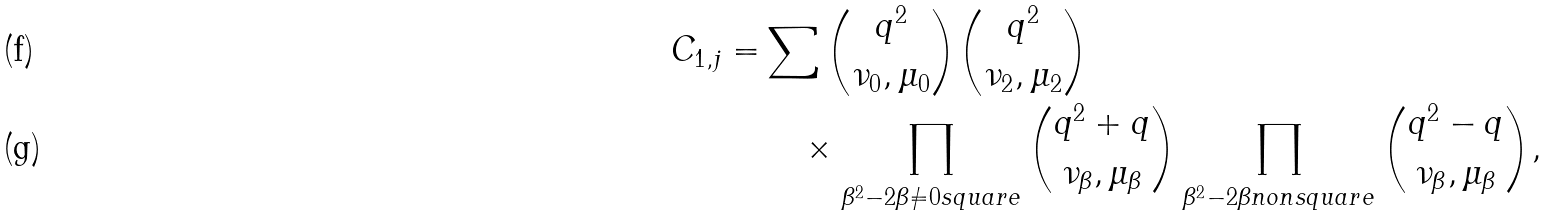Convert formula to latex. <formula><loc_0><loc_0><loc_500><loc_500>C _ { 1 , j } = & \sum { \binom { q ^ { 2 } } { \nu _ { 0 } , \mu _ { 0 } } } { \binom { q ^ { 2 } } { \nu _ { 2 } , \mu _ { 2 } } } \\ & \quad \times \prod _ { \beta ^ { 2 } - 2 \beta \neq 0 s q u a r e } { \binom { q ^ { 2 } + q } { \nu _ { \beta } , \mu _ { \beta } } } \prod _ { \beta ^ { 2 } - 2 \beta n o n s q u a r e } { \binom { q ^ { 2 } - q } { \nu _ { \beta } , \mu _ { \beta } } } ,</formula> 